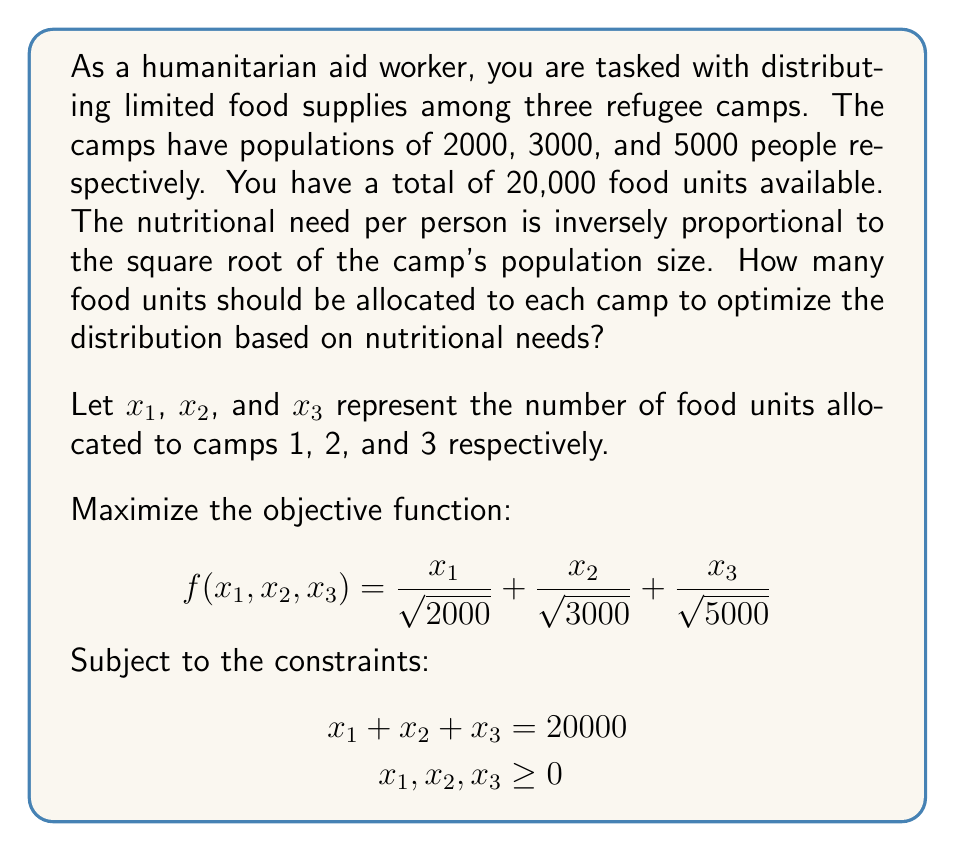Solve this math problem. To solve this optimization problem, we can use the method of Lagrange multipliers:

1) Form the Lagrangian function:
   $$L(x_1, x_2, x_3, \lambda) = \frac{x_1}{\sqrt{2000}} + \frac{x_2}{\sqrt{3000}} + \frac{x_3}{\sqrt{5000}} - \lambda(x_1 + x_2 + x_3 - 20000)$$

2) Take partial derivatives and set them equal to zero:
   $$\frac{\partial L}{\partial x_1} = \frac{1}{\sqrt{2000}} - \lambda = 0$$
   $$\frac{\partial L}{\partial x_2} = \frac{1}{\sqrt{3000}} - \lambda = 0$$
   $$\frac{\partial L}{\partial x_3} = \frac{1}{\sqrt{5000}} - \lambda = 0$$
   $$\frac{\partial L}{\partial \lambda} = -(x_1 + x_2 + x_3 - 20000) = 0$$

3) From the first three equations:
   $$\frac{1}{\sqrt{2000}} = \frac{1}{\sqrt{3000}} = \frac{1}{\sqrt{5000}} = \lambda$$

4) This implies:
   $$x_1 : x_2 : x_3 = \sqrt{2000} : \sqrt{3000} : \sqrt{5000}$$

5) Let $k$ be a constant. Then:
   $$x_1 = k\sqrt{2000}, x_2 = k\sqrt{3000}, x_3 = k\sqrt{5000}$$

6) Substitute into the constraint equation:
   $$k\sqrt{2000} + k\sqrt{3000} + k\sqrt{5000} = 20000$$
   $$k(\sqrt{2000} + \sqrt{3000} + \sqrt{5000}) = 20000$$
   $$k = \frac{20000}{\sqrt{2000} + \sqrt{3000} + \sqrt{5000}}$$

7) Calculate the final values:
   $$x_1 = \frac{20000 \cdot \sqrt{2000}}{\sqrt{2000} + \sqrt{3000} + \sqrt{5000}} \approx 5279$$
   $$x_2 = \frac{20000 \cdot \sqrt{3000}}{\sqrt{2000} + \sqrt{3000} + \sqrt{5000}} \approx 6466$$
   $$x_3 = \frac{20000 \cdot \sqrt{5000}}{\sqrt{2000} + \sqrt{3000} + \sqrt{5000}} \approx 8255$$
Answer: Camp 1: 5279 units, Camp 2: 6466 units, Camp 3: 8255 units 